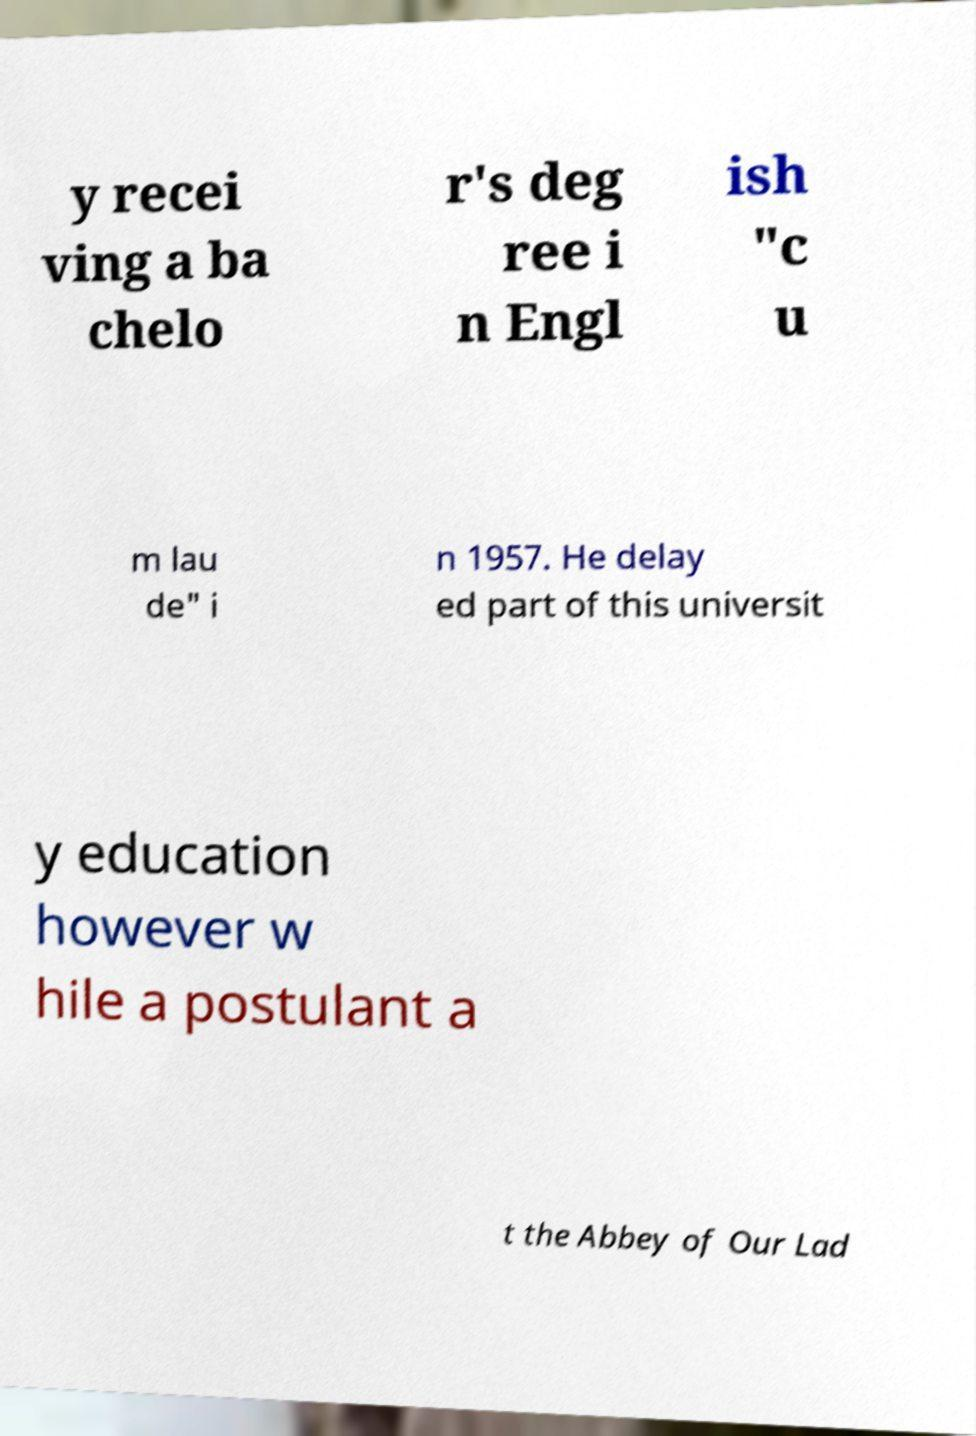I need the written content from this picture converted into text. Can you do that? y recei ving a ba chelo r's deg ree i n Engl ish "c u m lau de" i n 1957. He delay ed part of this universit y education however w hile a postulant a t the Abbey of Our Lad 